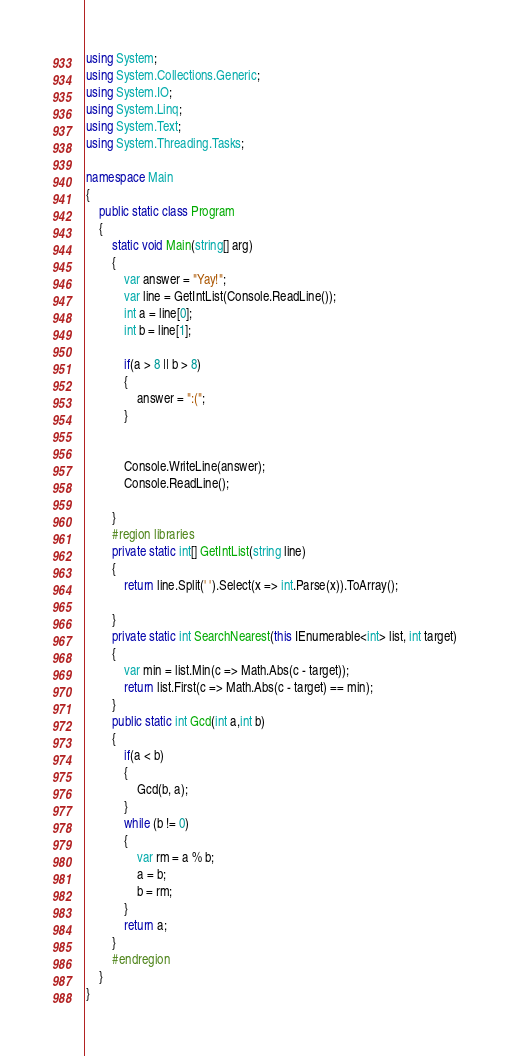Convert code to text. <code><loc_0><loc_0><loc_500><loc_500><_C#_>using System;
using System.Collections.Generic;
using System.IO;
using System.Linq;
using System.Text;
using System.Threading.Tasks;

namespace Main
{
    public static class Program
    {
        static void Main(string[] arg)
        {
            var answer = "Yay!";
            var line = GetIntList(Console.ReadLine());
            int a = line[0];
            int b = line[1];

            if(a > 8 || b > 8)
            {
                answer = ":(";
            }
            

            Console.WriteLine(answer);
            Console.ReadLine();

        }
        #region libraries
        private static int[] GetIntList(string line)
        {
            return line.Split(' ').Select(x => int.Parse(x)).ToArray();

        }
        private static int SearchNearest(this IEnumerable<int> list, int target)
        {
            var min = list.Min(c => Math.Abs(c - target));
            return list.First(c => Math.Abs(c - target) == min);
        }
        public static int Gcd(int a,int b)
        {
            if(a < b)
            {
                Gcd(b, a);
            }
            while (b != 0)
            {
                var rm = a % b;
                a = b;
                b = rm;
            }
            return a;
        }
        #endregion
    }
}
</code> 